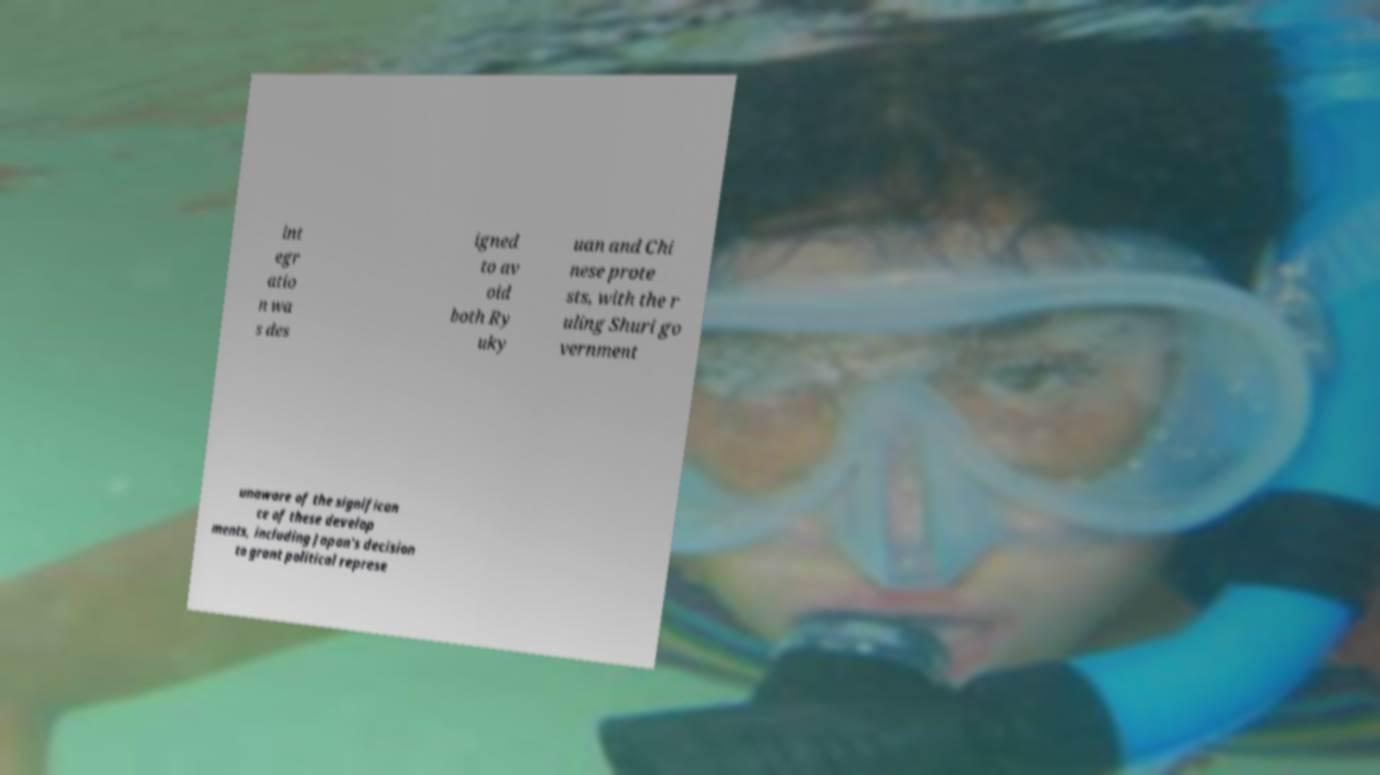What messages or text are displayed in this image? I need them in a readable, typed format. int egr atio n wa s des igned to av oid both Ry uky uan and Chi nese prote sts, with the r uling Shuri go vernment unaware of the significan ce of these develop ments, including Japan's decision to grant political represe 